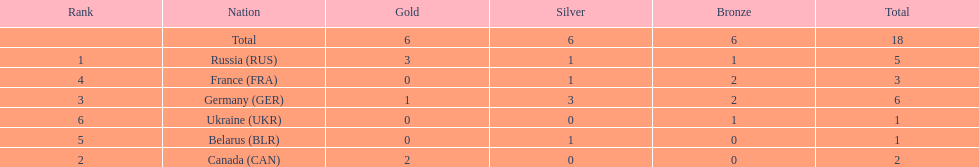What was the total number of silver medals awarded to the french and the germans in the 1994 winter olympic biathlon? 4. 